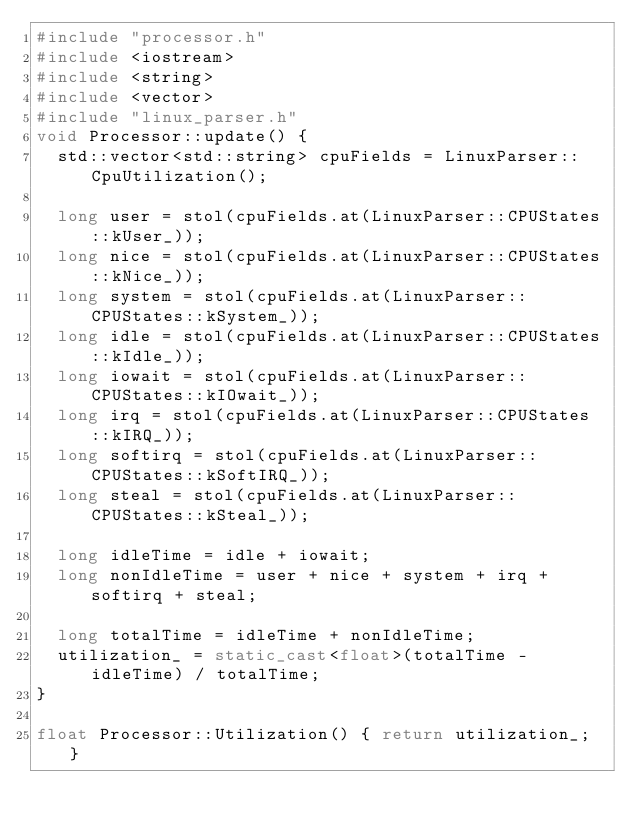Convert code to text. <code><loc_0><loc_0><loc_500><loc_500><_C++_>#include "processor.h"
#include <iostream>
#include <string>
#include <vector>
#include "linux_parser.h"
void Processor::update() {
  std::vector<std::string> cpuFields = LinuxParser::CpuUtilization();

  long user = stol(cpuFields.at(LinuxParser::CPUStates::kUser_));
  long nice = stol(cpuFields.at(LinuxParser::CPUStates::kNice_));
  long system = stol(cpuFields.at(LinuxParser::CPUStates::kSystem_));
  long idle = stol(cpuFields.at(LinuxParser::CPUStates::kIdle_));
  long iowait = stol(cpuFields.at(LinuxParser::CPUStates::kIOwait_));
  long irq = stol(cpuFields.at(LinuxParser::CPUStates::kIRQ_));
  long softirq = stol(cpuFields.at(LinuxParser::CPUStates::kSoftIRQ_));
  long steal = stol(cpuFields.at(LinuxParser::CPUStates::kSteal_));

  long idleTime = idle + iowait;
  long nonIdleTime = user + nice + system + irq + softirq + steal;

  long totalTime = idleTime + nonIdleTime;
  utilization_ = static_cast<float>(totalTime - idleTime) / totalTime;
}

float Processor::Utilization() { return utilization_; }</code> 